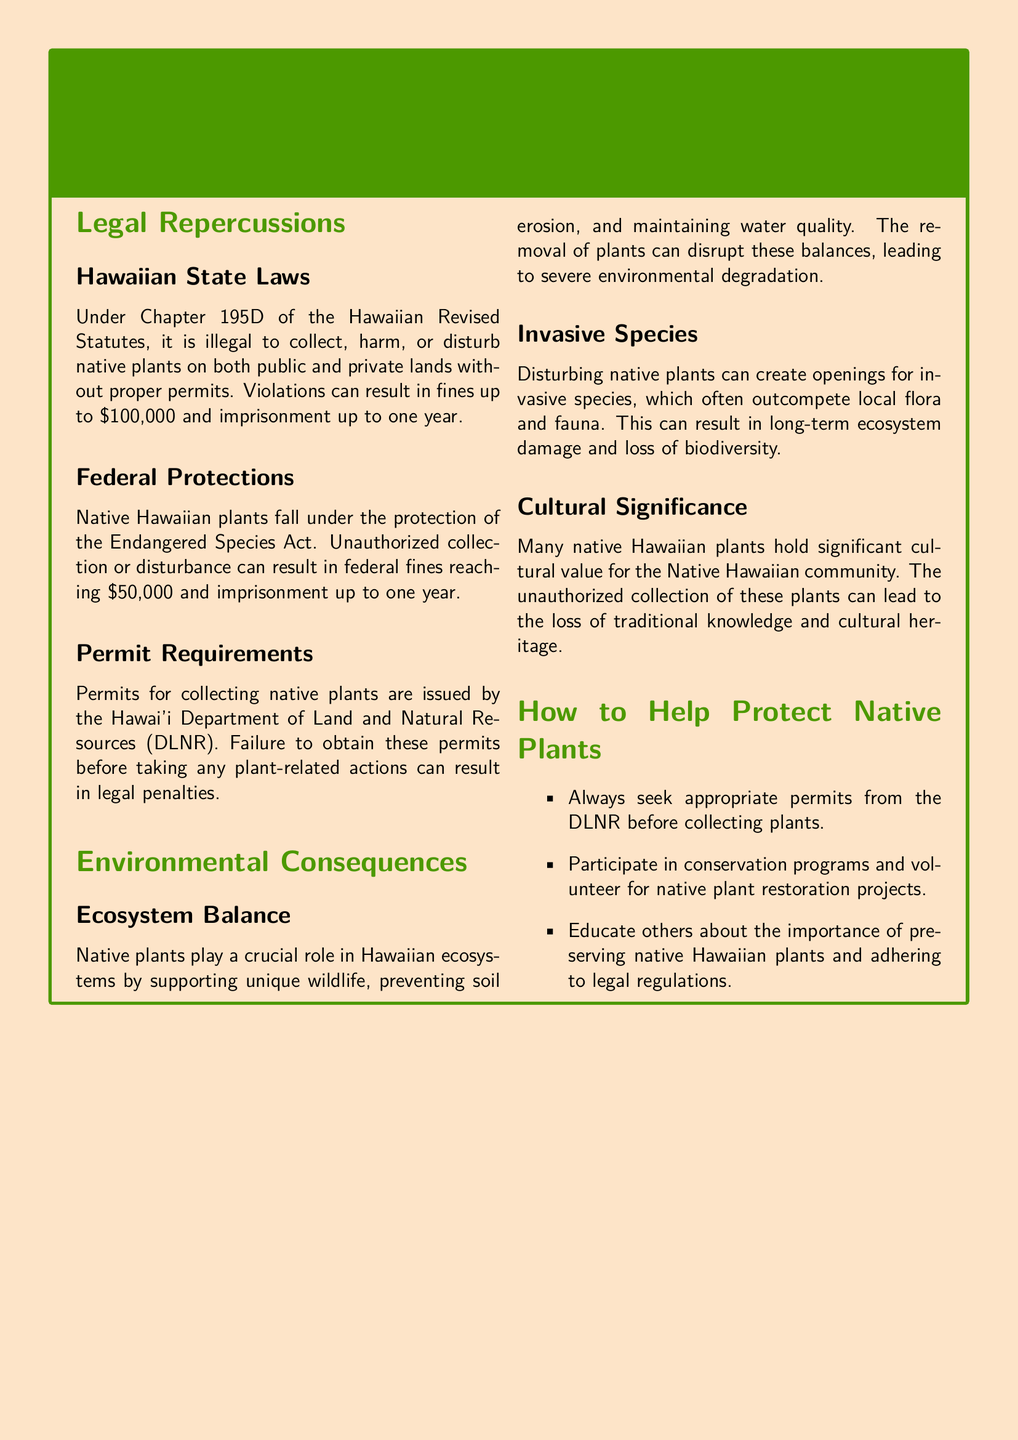What is the maximum fine for collecting native plants illegally? The document states that violations can result in fines up to $100,000.
Answer: $100,000 What department issues permits for collecting native plants? The document mentions that permits are issued by the Hawai'i Department of Land and Natural Resources (DLNR).
Answer: DLNR What federal law protects native Hawaiian plants? The document refers to the Endangered Species Act as the federal law that provides protection.
Answer: Endangered Species Act What can disturb the balance of ecosystems according to the document? The document explains that the removal of native plants can disrupt ecosystem balance.
Answer: Removal of native plants What is one consequence of disturbing native plants? The document indicates that disturbing native plants can create openings for invasive species.
Answer: Invasive species What can unauthorized collection of native plants lead to? The document states that it can lead to loss of traditional knowledge and cultural heritage.
Answer: Loss of traditional knowledge How can individuals help protect native plants? The document lists several ways including seeking permits, participating in conservation programs, and educating others.
Answer: Seek permits, conservation, educate What is the maximum imprisonment for collecting native plants without permits? The document specifies that violations can result in imprisonment up to one year.
Answer: One year 